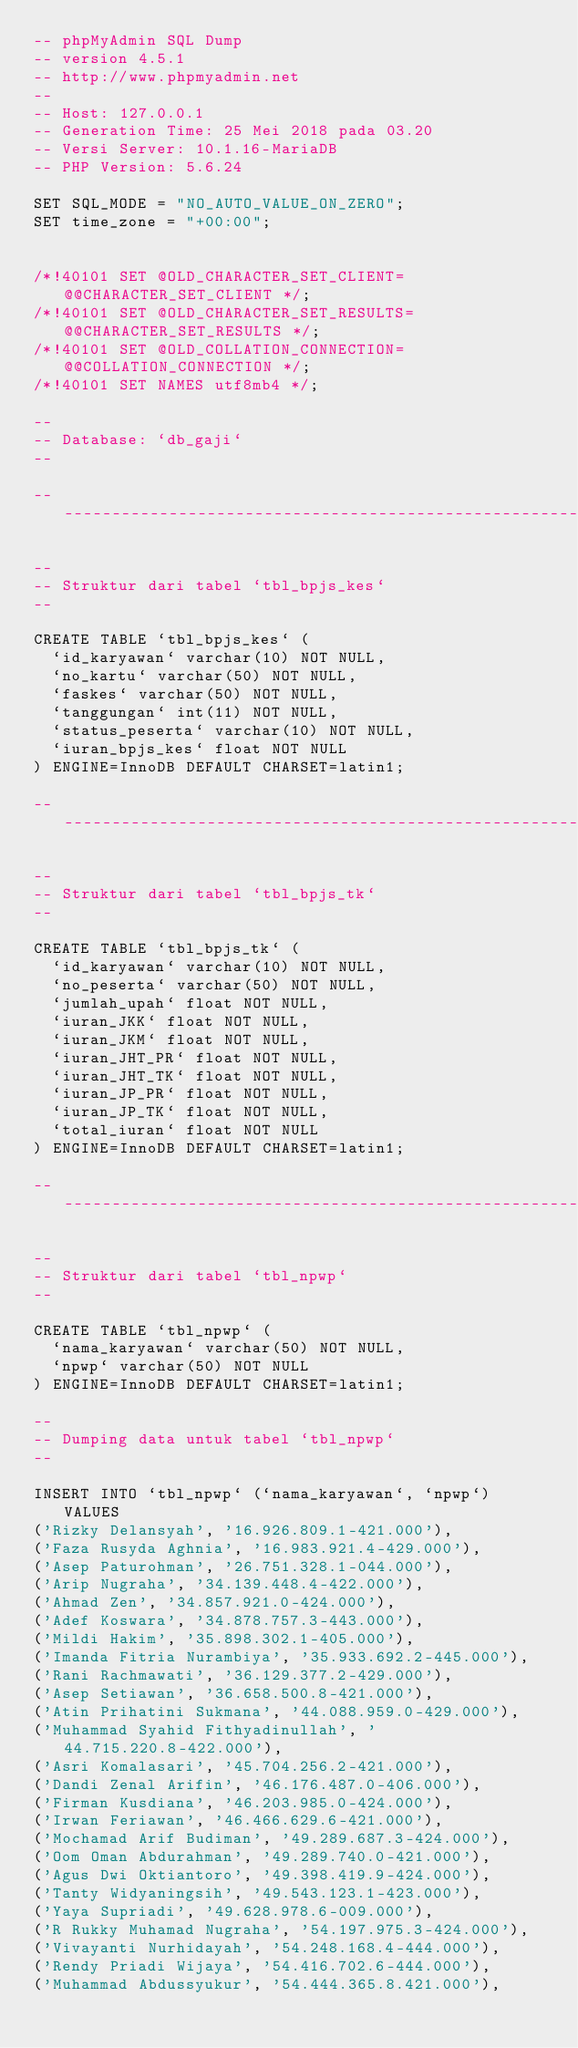<code> <loc_0><loc_0><loc_500><loc_500><_SQL_>-- phpMyAdmin SQL Dump
-- version 4.5.1
-- http://www.phpmyadmin.net
--
-- Host: 127.0.0.1
-- Generation Time: 25 Mei 2018 pada 03.20
-- Versi Server: 10.1.16-MariaDB
-- PHP Version: 5.6.24

SET SQL_MODE = "NO_AUTO_VALUE_ON_ZERO";
SET time_zone = "+00:00";


/*!40101 SET @OLD_CHARACTER_SET_CLIENT=@@CHARACTER_SET_CLIENT */;
/*!40101 SET @OLD_CHARACTER_SET_RESULTS=@@CHARACTER_SET_RESULTS */;
/*!40101 SET @OLD_COLLATION_CONNECTION=@@COLLATION_CONNECTION */;
/*!40101 SET NAMES utf8mb4 */;

--
-- Database: `db_gaji`
--

-- --------------------------------------------------------

--
-- Struktur dari tabel `tbl_bpjs_kes`
--

CREATE TABLE `tbl_bpjs_kes` (
  `id_karyawan` varchar(10) NOT NULL,
  `no_kartu` varchar(50) NOT NULL,
  `faskes` varchar(50) NOT NULL,
  `tanggungan` int(11) NOT NULL,
  `status_peserta` varchar(10) NOT NULL,
  `iuran_bpjs_kes` float NOT NULL
) ENGINE=InnoDB DEFAULT CHARSET=latin1;

-- --------------------------------------------------------

--
-- Struktur dari tabel `tbl_bpjs_tk`
--

CREATE TABLE `tbl_bpjs_tk` (
  `id_karyawan` varchar(10) NOT NULL,
  `no_peserta` varchar(50) NOT NULL,
  `jumlah_upah` float NOT NULL,
  `iuran_JKK` float NOT NULL,
  `iuran_JKM` float NOT NULL,
  `iuran_JHT_PR` float NOT NULL,
  `iuran_JHT_TK` float NOT NULL,
  `iuran_JP_PR` float NOT NULL,
  `iuran_JP_TK` float NOT NULL,
  `total_iuran` float NOT NULL
) ENGINE=InnoDB DEFAULT CHARSET=latin1;

-- --------------------------------------------------------

--
-- Struktur dari tabel `tbl_npwp`
--

CREATE TABLE `tbl_npwp` (
  `nama_karyawan` varchar(50) NOT NULL,
  `npwp` varchar(50) NOT NULL
) ENGINE=InnoDB DEFAULT CHARSET=latin1;

--
-- Dumping data untuk tabel `tbl_npwp`
--

INSERT INTO `tbl_npwp` (`nama_karyawan`, `npwp`) VALUES
('Rizky Delansyah', '16.926.809.1-421.000'),
('Faza Rusyda Aghnia', '16.983.921.4-429.000'),
('Asep Paturohman', '26.751.328.1-044.000'),
('Arip Nugraha', '34.139.448.4-422.000'),
('Ahmad Zen', '34.857.921.0-424.000'),
('Adef Koswara', '34.878.757.3-443.000'),
('Mildi Hakim', '35.898.302.1-405.000'),
('Imanda Fitria Nurambiya', '35.933.692.2-445.000'),
('Rani Rachmawati', '36.129.377.2-429.000'),
('Asep Setiawan', '36.658.500.8-421.000'),
('Atin Prihatini Sukmana', '44.088.959.0-429.000'),
('Muhammad Syahid Fithyadinullah', '44.715.220.8-422.000'),
('Asri Komalasari', '45.704.256.2-421.000'),
('Dandi Zenal Arifin', '46.176.487.0-406.000'),
('Firman Kusdiana', '46.203.985.0-424.000'),
('Irwan Feriawan', '46.466.629.6-421.000'),
('Mochamad Arif Budiman', '49.289.687.3-424.000'),
('Oom Oman Abdurahman', '49.289.740.0-421.000'),
('Agus Dwi Oktiantoro', '49.398.419.9-424.000'),
('Tanty Widyaningsih', '49.543.123.1-423.000'),
('Yaya Supriadi', '49.628.978.6-009.000'),
('R Rukky Muhamad Nugraha', '54.197.975.3-424.000'),
('Vivayanti Nurhidayah', '54.248.168.4-444.000'),
('Rendy Priadi Wijaya', '54.416.702.6-444.000'),
('Muhammad Abdussyukur', '54.444.365.8.421.000'),</code> 